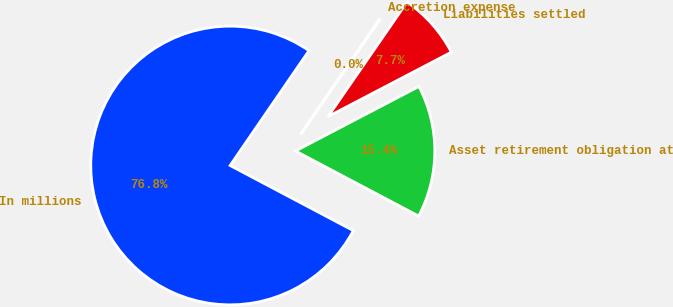<chart> <loc_0><loc_0><loc_500><loc_500><pie_chart><fcel>In millions<fcel>Asset retirement obligation at<fcel>Liabilities settled<fcel>Accretion expense<nl><fcel>76.84%<fcel>15.4%<fcel>7.72%<fcel>0.04%<nl></chart> 